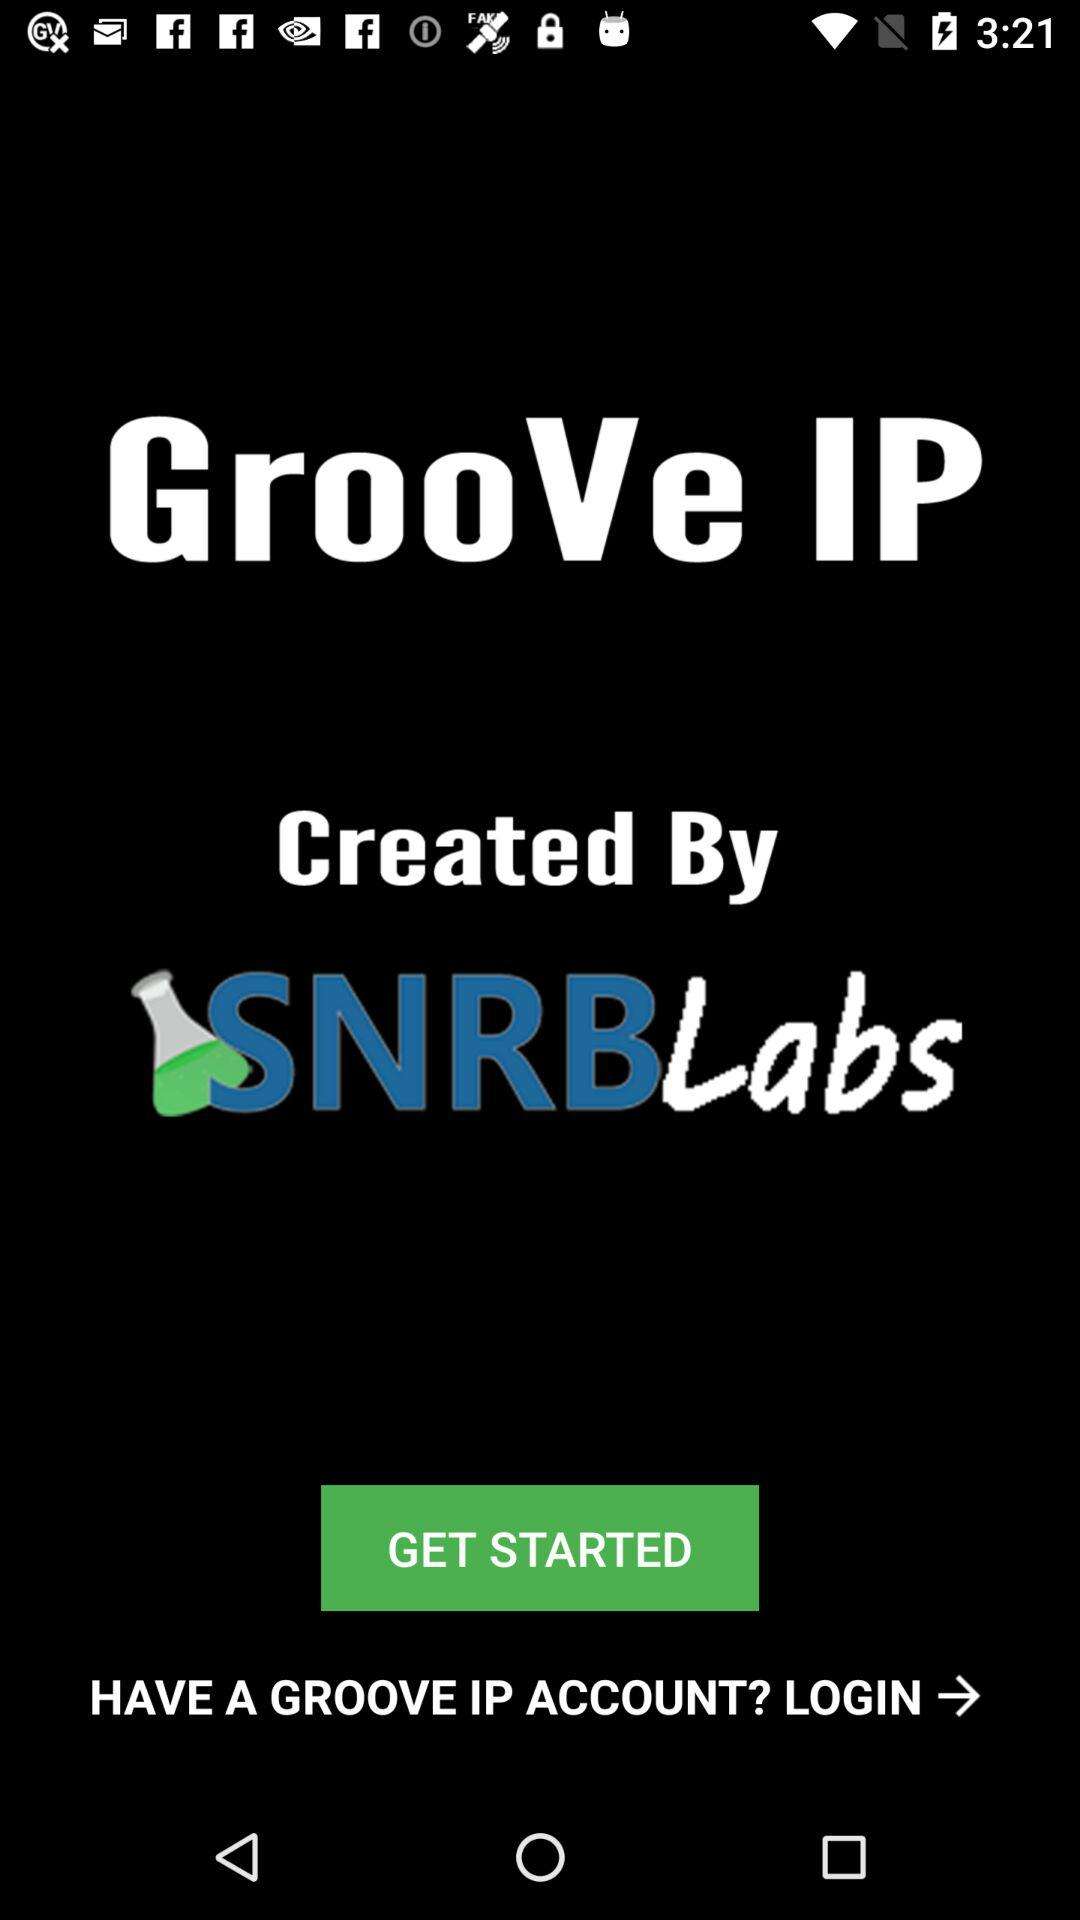Who developed the application? The application was developed by "SNRBLabs". 